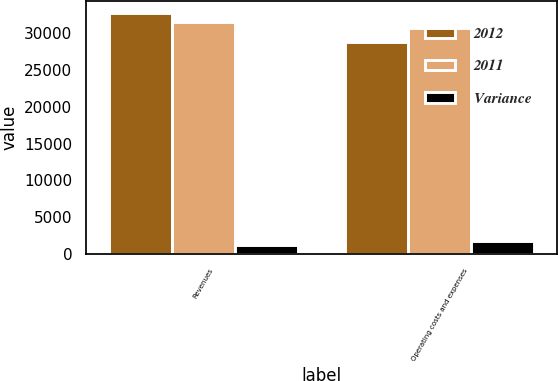<chart> <loc_0><loc_0><loc_500><loc_500><stacked_bar_chart><ecel><fcel>Revenues<fcel>Operating costs and expenses<nl><fcel>2012<fcel>32677<fcel>28851<nl><fcel>2011<fcel>31513<fcel>30680<nl><fcel>Variance<fcel>1164<fcel>1829<nl></chart> 